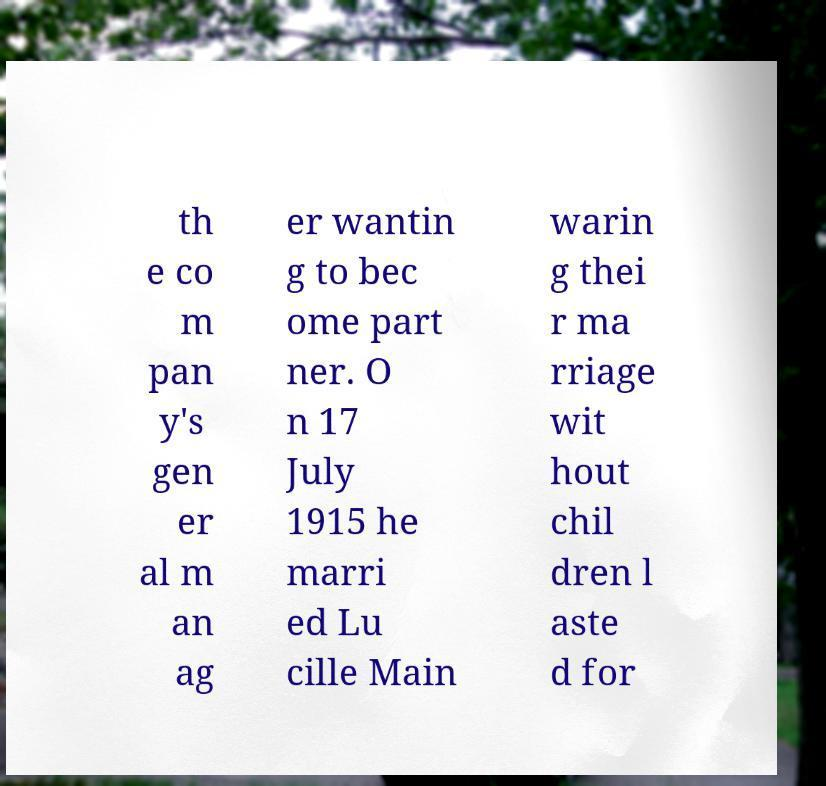What messages or text are displayed in this image? I need them in a readable, typed format. th e co m pan y's gen er al m an ag er wantin g to bec ome part ner. O n 17 July 1915 he marri ed Lu cille Main warin g thei r ma rriage wit hout chil dren l aste d for 